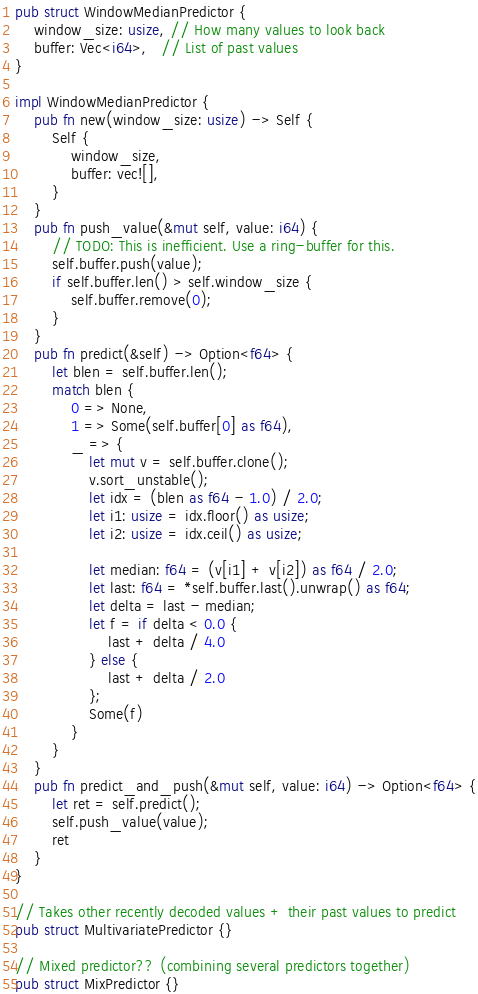Convert code to text. <code><loc_0><loc_0><loc_500><loc_500><_Rust_>pub struct WindowMedianPredictor {
    window_size: usize, // How many values to look back
    buffer: Vec<i64>,   // List of past values
}

impl WindowMedianPredictor {
    pub fn new(window_size: usize) -> Self {
        Self {
            window_size,
            buffer: vec![],
        }
    }
    pub fn push_value(&mut self, value: i64) {
        // TODO: This is inefficient. Use a ring-buffer for this.
        self.buffer.push(value);
        if self.buffer.len() > self.window_size {
            self.buffer.remove(0);
        }
    }
    pub fn predict(&self) -> Option<f64> {
        let blen = self.buffer.len();
        match blen {
            0 => None,
            1 => Some(self.buffer[0] as f64),
            _ => {
                let mut v = self.buffer.clone();
                v.sort_unstable();
                let idx = (blen as f64 - 1.0) / 2.0;
                let i1: usize = idx.floor() as usize;
                let i2: usize = idx.ceil() as usize;

                let median: f64 = (v[i1] + v[i2]) as f64 / 2.0;
                let last: f64 = *self.buffer.last().unwrap() as f64;
                let delta = last - median;
                let f = if delta < 0.0 {
                    last + delta / 4.0
                } else {
                    last + delta / 2.0
                };
                Some(f)
            }
        }
    }
    pub fn predict_and_push(&mut self, value: i64) -> Option<f64> {
        let ret = self.predict();
        self.push_value(value);
        ret
    }
}

// Takes other recently decoded values + their past values to predict
pub struct MultivariatePredictor {}

// Mixed predictor?? (combining several predictors together)
pub struct MixPredictor {}
</code> 